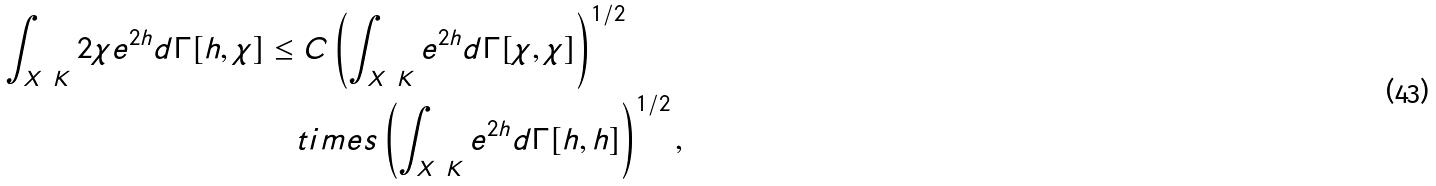Convert formula to latex. <formula><loc_0><loc_0><loc_500><loc_500>\int _ { X \ K } 2 \chi e ^ { 2 h } d \Gamma [ h , \chi ] & \leq C \left ( \int _ { X \ K } e ^ { 2 h } d \Gamma [ \chi , \chi ] \right ) ^ { 1 / 2 } \\ & \quad t i m e s \left ( \int _ { X \ K } e ^ { 2 h } d \Gamma [ h , h ] \right ) ^ { 1 / 2 } ,</formula> 